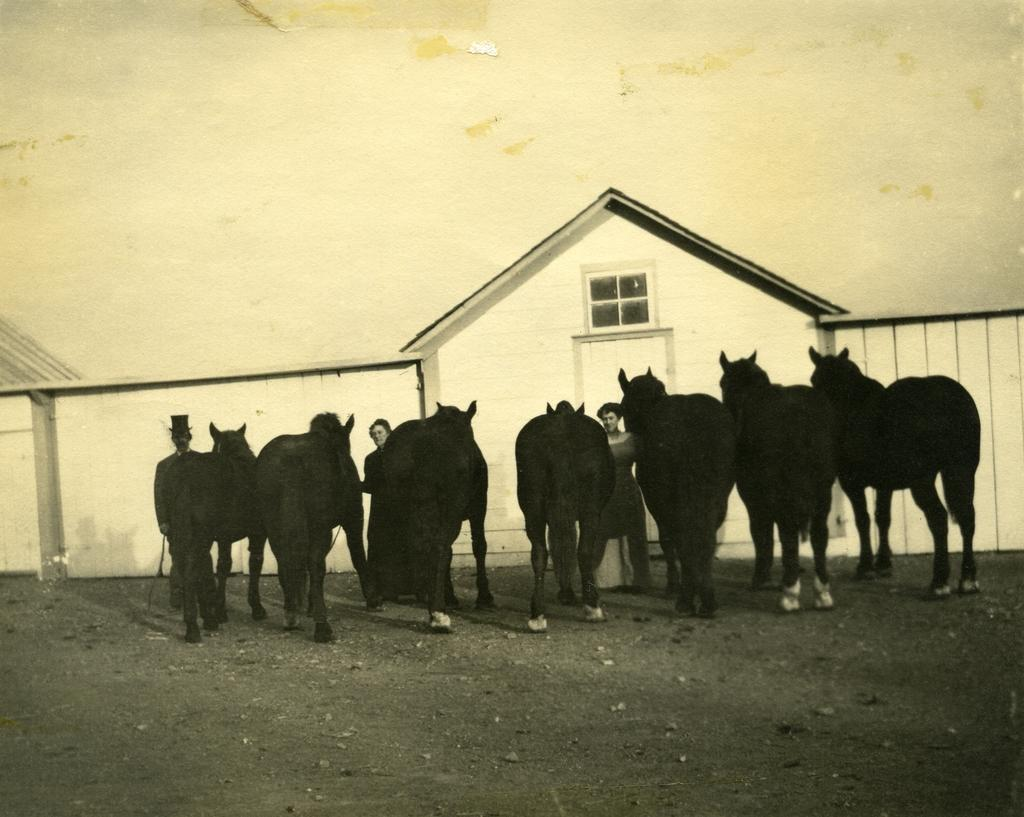How many people are present in the image? There are three people in the image. What are the people doing with the animals? The people are holding the animals in the image. What can be seen in the background of the image? There is a wall, a door, and a window in the background of the image. What type of pan is being used to cook the animals in the image? There is no pan or cooking activity present in the image; the people are simply holding the animals. 